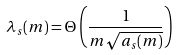Convert formula to latex. <formula><loc_0><loc_0><loc_500><loc_500>\lambda _ { s } ( m ) = \Theta \left ( \frac { 1 } { m \sqrt { a _ { s } ( m ) } } \right )</formula> 